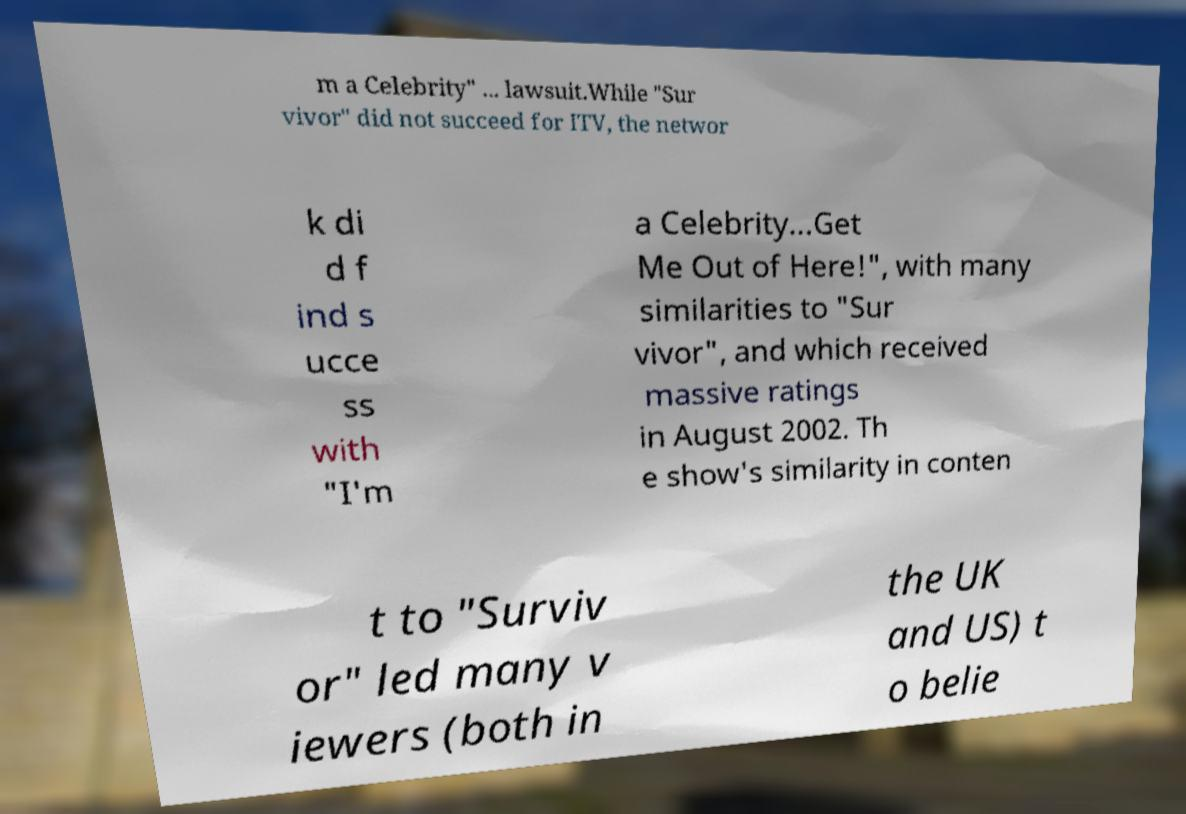Please read and relay the text visible in this image. What does it say? m a Celebrity" ... lawsuit.While "Sur vivor" did not succeed for ITV, the networ k di d f ind s ucce ss with "I'm a Celebrity...Get Me Out of Here!", with many similarities to "Sur vivor", and which received massive ratings in August 2002. Th e show's similarity in conten t to "Surviv or" led many v iewers (both in the UK and US) t o belie 